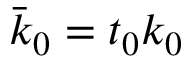<formula> <loc_0><loc_0><loc_500><loc_500>\bar { k } _ { 0 } = t _ { 0 } k _ { 0 }</formula> 